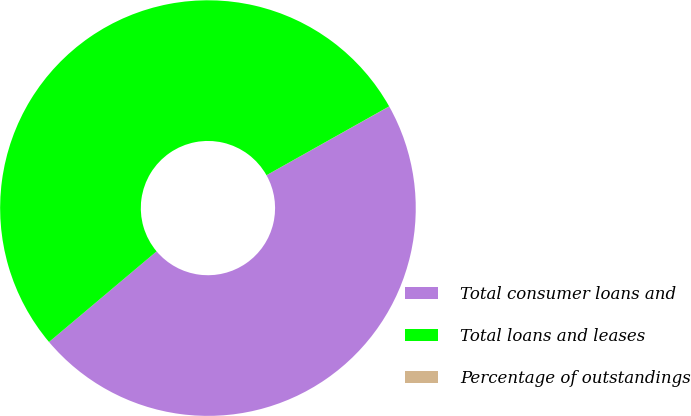Convert chart. <chart><loc_0><loc_0><loc_500><loc_500><pie_chart><fcel>Total consumer loans and<fcel>Total loans and leases<fcel>Percentage of outstandings<nl><fcel>46.99%<fcel>53.01%<fcel>0.01%<nl></chart> 